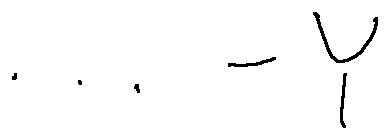Convert formula to latex. <formula><loc_0><loc_0><loc_500><loc_500>\cdots - Y</formula> 